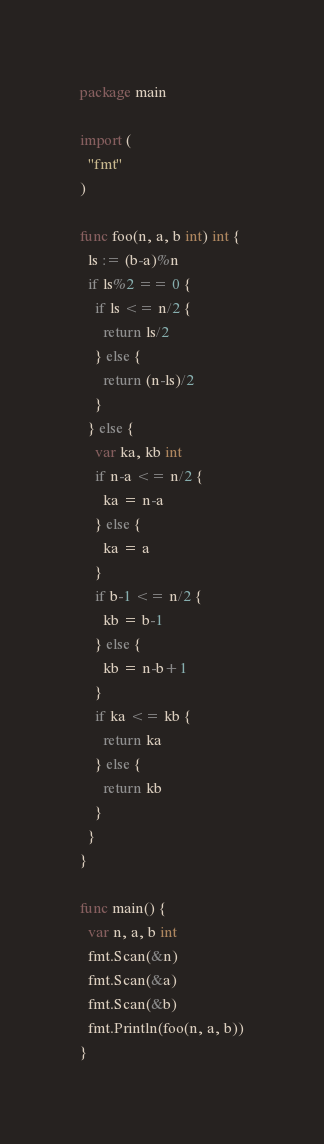Convert code to text. <code><loc_0><loc_0><loc_500><loc_500><_Go_>package main
 
import (
  "fmt"
)
 
func foo(n, a, b int) int {
  ls := (b-a)%n
  if ls%2 == 0 {
    if ls <= n/2 {
      return ls/2
    } else {
      return (n-ls)/2
    }
  } else {
    var ka, kb int
    if n-a <= n/2 {
      ka = n-a
    } else {
      ka = a
    }
    if b-1 <= n/2 {
      kb = b-1
    } else {
      kb = n-b+1
    }
    if ka <= kb {
      return ka
    } else {
      return kb
    }
  }
}
 
func main() {
  var n, a, b int
  fmt.Scan(&n)
  fmt.Scan(&a)
  fmt.Scan(&b)
  fmt.Println(foo(n, a, b))
}</code> 